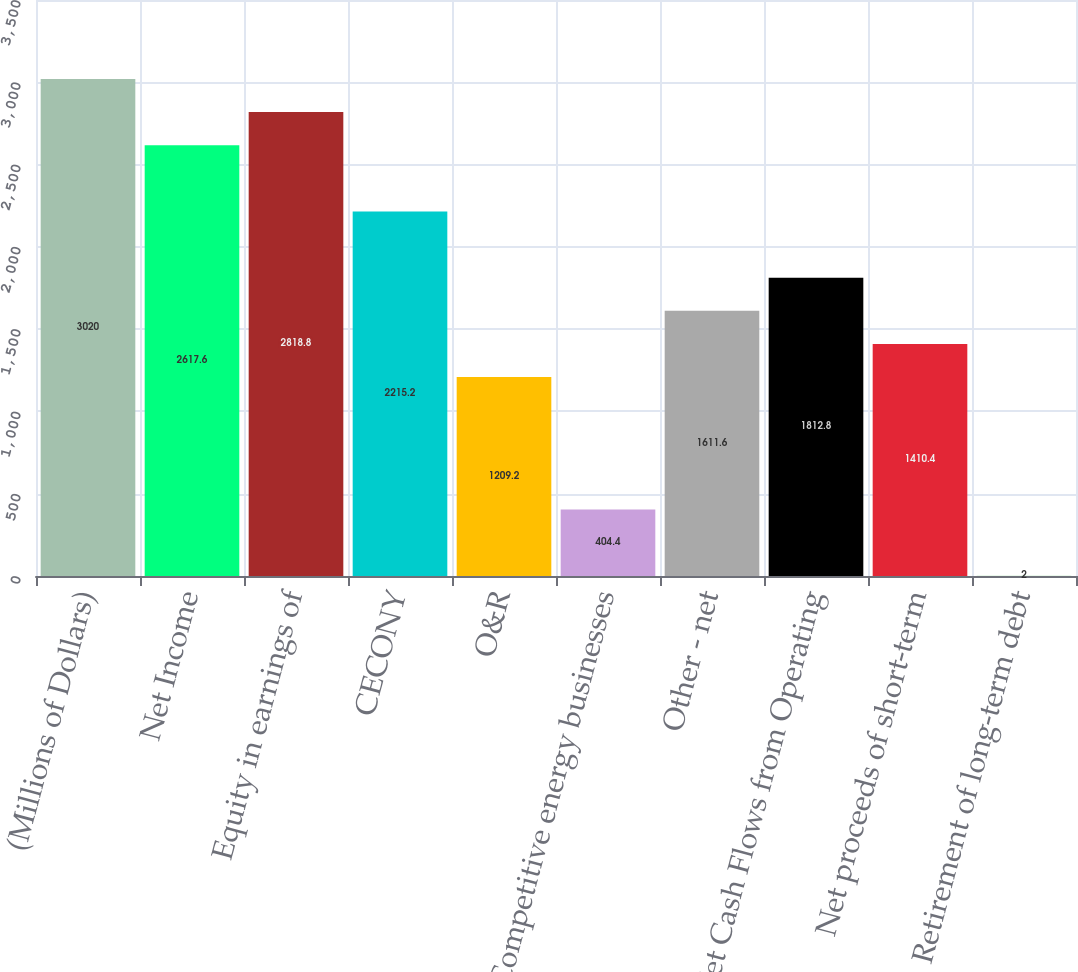<chart> <loc_0><loc_0><loc_500><loc_500><bar_chart><fcel>(Millions of Dollars)<fcel>Net Income<fcel>Equity in earnings of<fcel>CECONY<fcel>O&R<fcel>Competitive energy businesses<fcel>Other - net<fcel>Net Cash Flows from Operating<fcel>Net proceeds of short-term<fcel>Retirement of long-term debt<nl><fcel>3020<fcel>2617.6<fcel>2818.8<fcel>2215.2<fcel>1209.2<fcel>404.4<fcel>1611.6<fcel>1812.8<fcel>1410.4<fcel>2<nl></chart> 